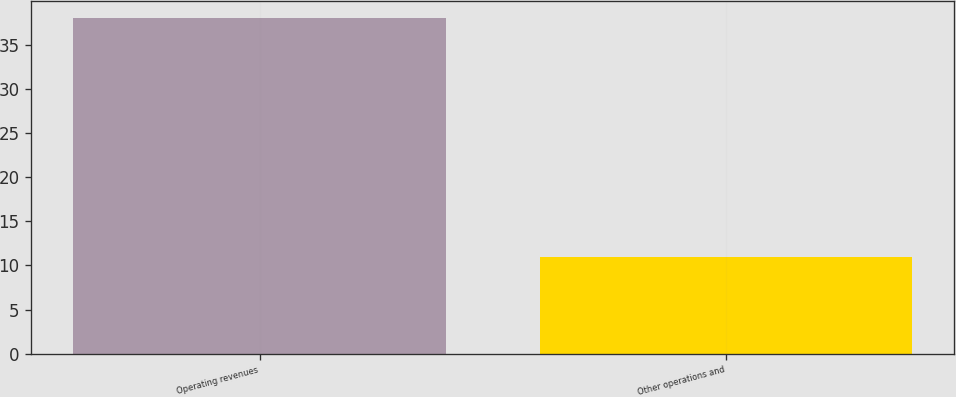Convert chart. <chart><loc_0><loc_0><loc_500><loc_500><bar_chart><fcel>Operating revenues<fcel>Other operations and<nl><fcel>38<fcel>11<nl></chart> 